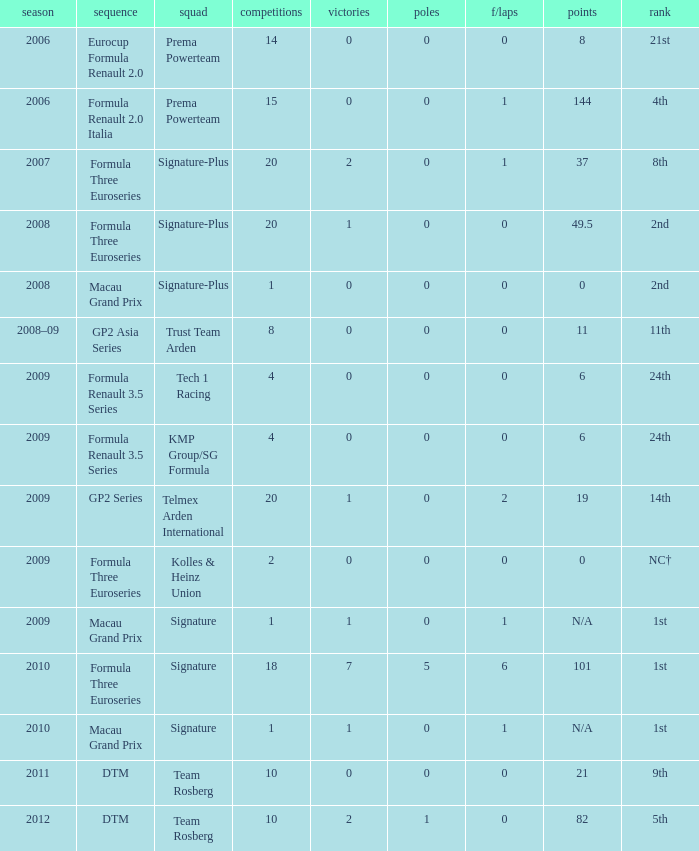How many poles are there in the Formula Three Euroseries in the 2008 season with more than 0 F/Laps? None. 